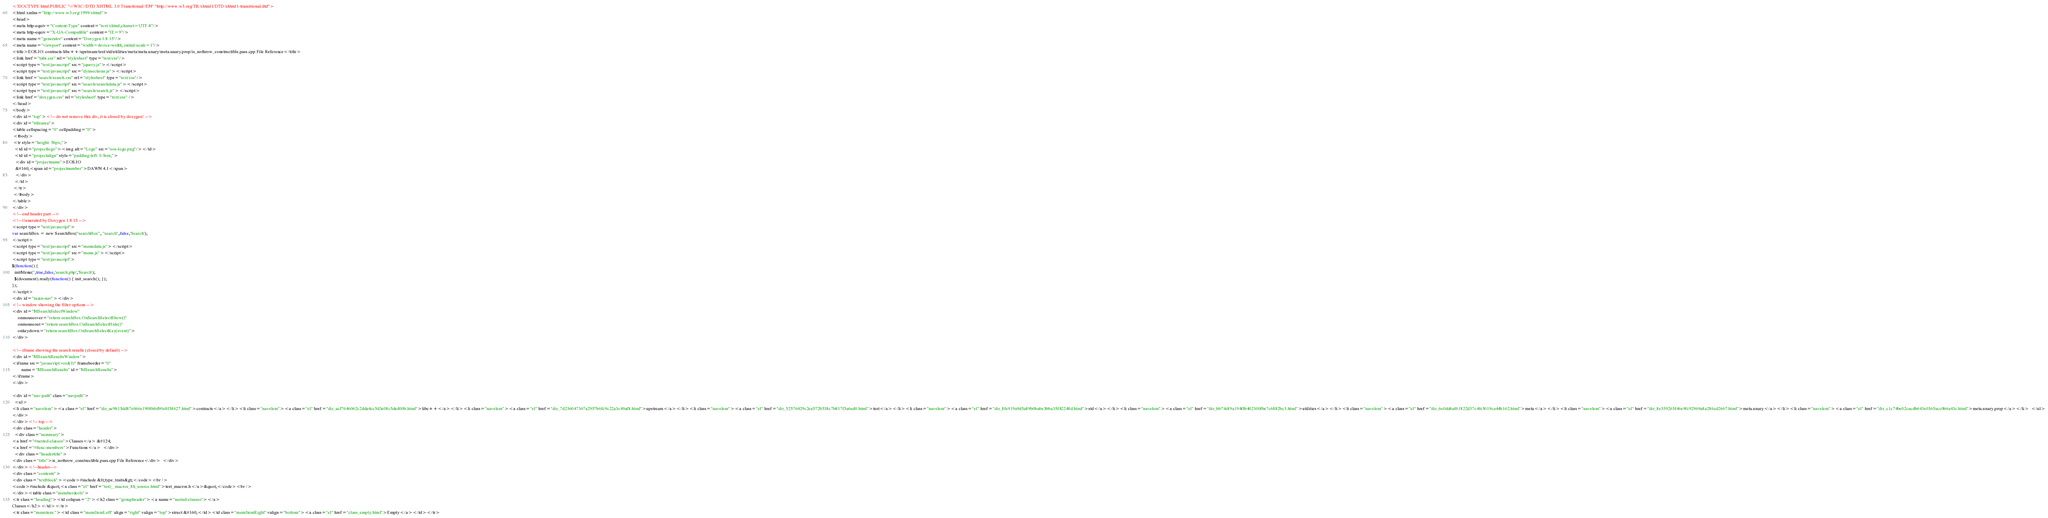Convert code to text. <code><loc_0><loc_0><loc_500><loc_500><_HTML_><!DOCTYPE html PUBLIC "-//W3C//DTD XHTML 1.0 Transitional//EN" "http://www.w3.org/TR/xhtml1/DTD/xhtml1-transitional.dtd">
<html xmlns="http://www.w3.org/1999/xhtml">
<head>
<meta http-equiv="Content-Type" content="text/xhtml;charset=UTF-8"/>
<meta http-equiv="X-UA-Compatible" content="IE=9"/>
<meta name="generator" content="Doxygen 1.8.13"/>
<meta name="viewport" content="width=device-width, initial-scale=1"/>
<title>EOS.IO: contracts/libc++/upstream/test/std/utilities/meta/meta.unary/meta.unary.prop/is_nothrow_constructible.pass.cpp File Reference</title>
<link href="tabs.css" rel="stylesheet" type="text/css"/>
<script type="text/javascript" src="jquery.js"></script>
<script type="text/javascript" src="dynsections.js"></script>
<link href="search/search.css" rel="stylesheet" type="text/css"/>
<script type="text/javascript" src="search/searchdata.js"></script>
<script type="text/javascript" src="search/search.js"></script>
<link href="doxygen.css" rel="stylesheet" type="text/css" />
</head>
<body>
<div id="top"><!-- do not remove this div, it is closed by doxygen! -->
<div id="titlearea">
<table cellspacing="0" cellpadding="0">
 <tbody>
 <tr style="height: 56px;">
  <td id="projectlogo"><img alt="Logo" src="eos-logo.png"/></td>
  <td id="projectalign" style="padding-left: 0.5em;">
   <div id="projectname">EOS.IO
   &#160;<span id="projectnumber">DAWN 4.1</span>
   </div>
  </td>
 </tr>
 </tbody>
</table>
</div>
<!-- end header part -->
<!-- Generated by Doxygen 1.8.13 -->
<script type="text/javascript">
var searchBox = new SearchBox("searchBox", "search",false,'Search');
</script>
<script type="text/javascript" src="menudata.js"></script>
<script type="text/javascript" src="menu.js"></script>
<script type="text/javascript">
$(function() {
  initMenu('',true,false,'search.php','Search');
  $(document).ready(function() { init_search(); });
});
</script>
<div id="main-nav"></div>
<!-- window showing the filter options -->
<div id="MSearchSelectWindow"
     onmouseover="return searchBox.OnSearchSelectShow()"
     onmouseout="return searchBox.OnSearchSelectHide()"
     onkeydown="return searchBox.OnSearchSelectKey(event)">
</div>

<!-- iframe showing the search results (closed by default) -->
<div id="MSearchResultsWindow">
<iframe src="javascript:void(0)" frameborder="0" 
        name="MSearchResults" id="MSearchResults">
</iframe>
</div>

<div id="nav-path" class="navpath">
  <ul>
<li class="navelem"><a class="el" href="dir_ae9b15dd87e066e1908bbd90e8f38627.html">contracts</a></li><li class="navelem"><a class="el" href="dir_acf7646062c2dda4cc5d3e08c5ded00b.html">libc++</a></li><li class="navelem"><a class="el" href="dir_7d236047367a2957b6fc9c22a3c49af8.html">upstream</a></li><li class="navelem"><a class="el" href="dir_52576429c2ea572b538c7b817f3a6ed0.html">test</a></li><li class="navelem"><a class="el" href="dir_8fe919a9d5a89b0babe3bba35f42248d.html">std</a></li><li class="navelem"><a class="el" href="dir_bb74c89a194ffb402300fbe7c6882bc3.html">utilities</a></li><li class="navelem"><a class="el" href="dir_6e0dd6af61822d37c4fe5019ca44b162.html">meta</a></li><li class="navelem"><a class="el" href="dir_8e339265f46e9fc92969a8a286cd2667.html">meta.unary</a></li><li class="navelem"><a class="el" href="dir_c1c74be02cacdb643e0365acc0b6a43c.html">meta.unary.prop</a></li>  </ul>
</div>
</div><!-- top -->
<div class="header">
  <div class="summary">
<a href="#nested-classes">Classes</a> &#124;
<a href="#func-members">Functions</a>  </div>
  <div class="headertitle">
<div class="title">is_nothrow_constructible.pass.cpp File Reference</div>  </div>
</div><!--header-->
<div class="contents">
<div class="textblock"><code>#include &lt;type_traits&gt;</code><br />
<code>#include &quot;<a class="el" href="test__macros_8h_source.html">test_macros.h</a>&quot;</code><br />
</div><table class="memberdecls">
<tr class="heading"><td colspan="2"><h2 class="groupheader"><a name="nested-classes"></a>
Classes</h2></td></tr>
<tr class="memitem:"><td class="memItemLeft" align="right" valign="top">struct &#160;</td><td class="memItemRight" valign="bottom"><a class="el" href="class_empty.html">Empty</a></td></tr></code> 